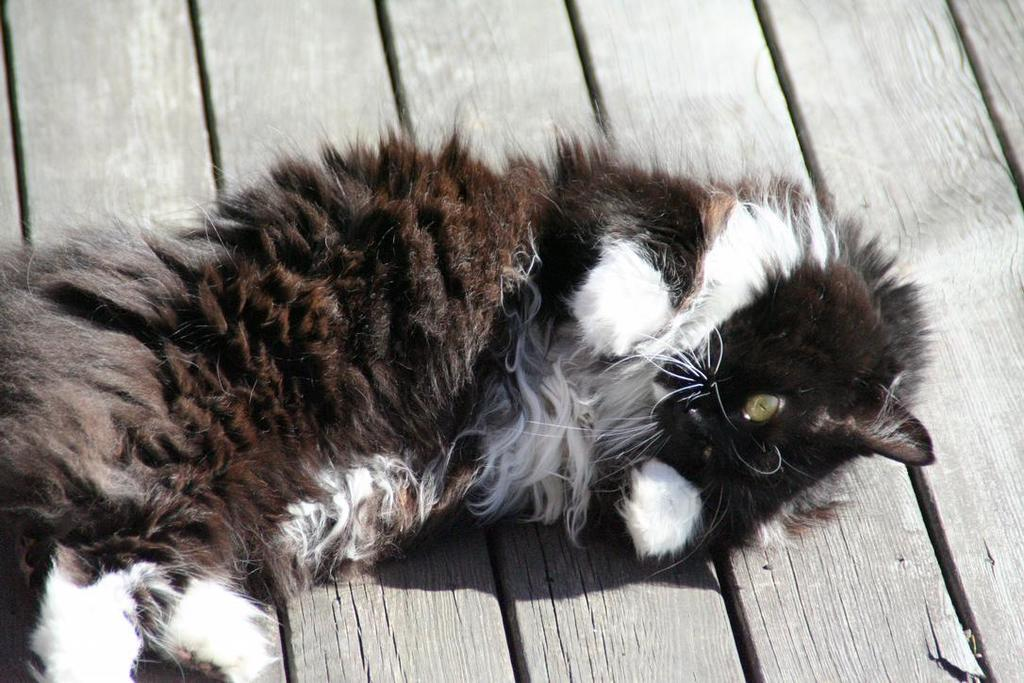What type of animal is present in the image? There is a cat in the image. Can you describe the cat's position in the image? The cat is laying on the wooden floor. What type of button is the cat using to communicate with the committee in the image? There is no button or committee present in the image; it only features a cat laying on the wooden floor. 